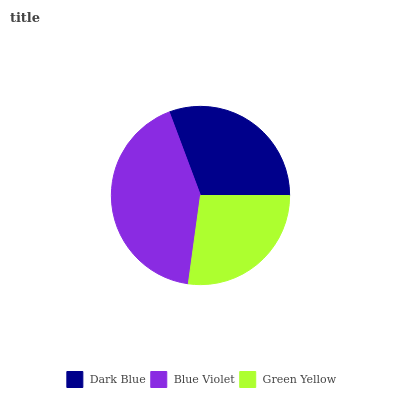Is Green Yellow the minimum?
Answer yes or no. Yes. Is Blue Violet the maximum?
Answer yes or no. Yes. Is Blue Violet the minimum?
Answer yes or no. No. Is Green Yellow the maximum?
Answer yes or no. No. Is Blue Violet greater than Green Yellow?
Answer yes or no. Yes. Is Green Yellow less than Blue Violet?
Answer yes or no. Yes. Is Green Yellow greater than Blue Violet?
Answer yes or no. No. Is Blue Violet less than Green Yellow?
Answer yes or no. No. Is Dark Blue the high median?
Answer yes or no. Yes. Is Dark Blue the low median?
Answer yes or no. Yes. Is Blue Violet the high median?
Answer yes or no. No. Is Green Yellow the low median?
Answer yes or no. No. 